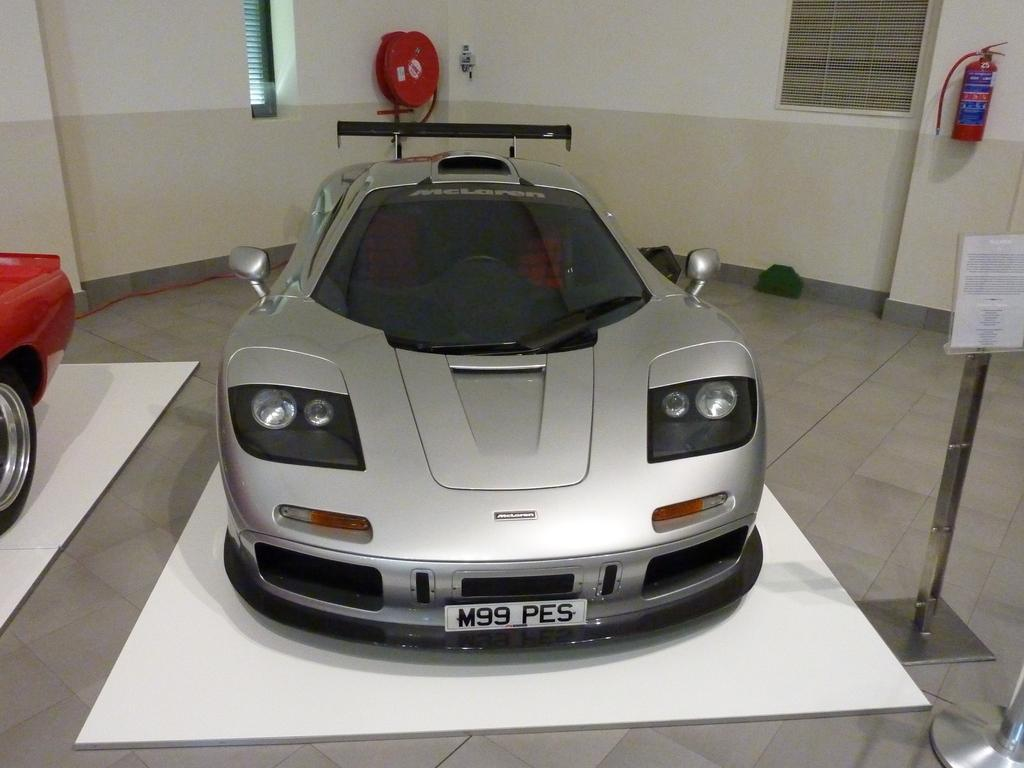What is the main subject of the image? The main subject of the image is a car. Can you describe the car's appearance? The car is silver in color. Where is the car located in the image? The car is in the middle of the image. What else can be seen in the image besides the car? There is a fire extinguisher on the wall in the image. On which side of the image is the fire extinguisher located? The fire extinguisher is on the right side of the image. How does the car get a rest in the image? The car does not get a rest in the image; it is stationary and not in motion. Can you tell me if the person in the image is getting a haircut? There is no person visible in the image, so it cannot be determined if anyone is getting a haircut. 